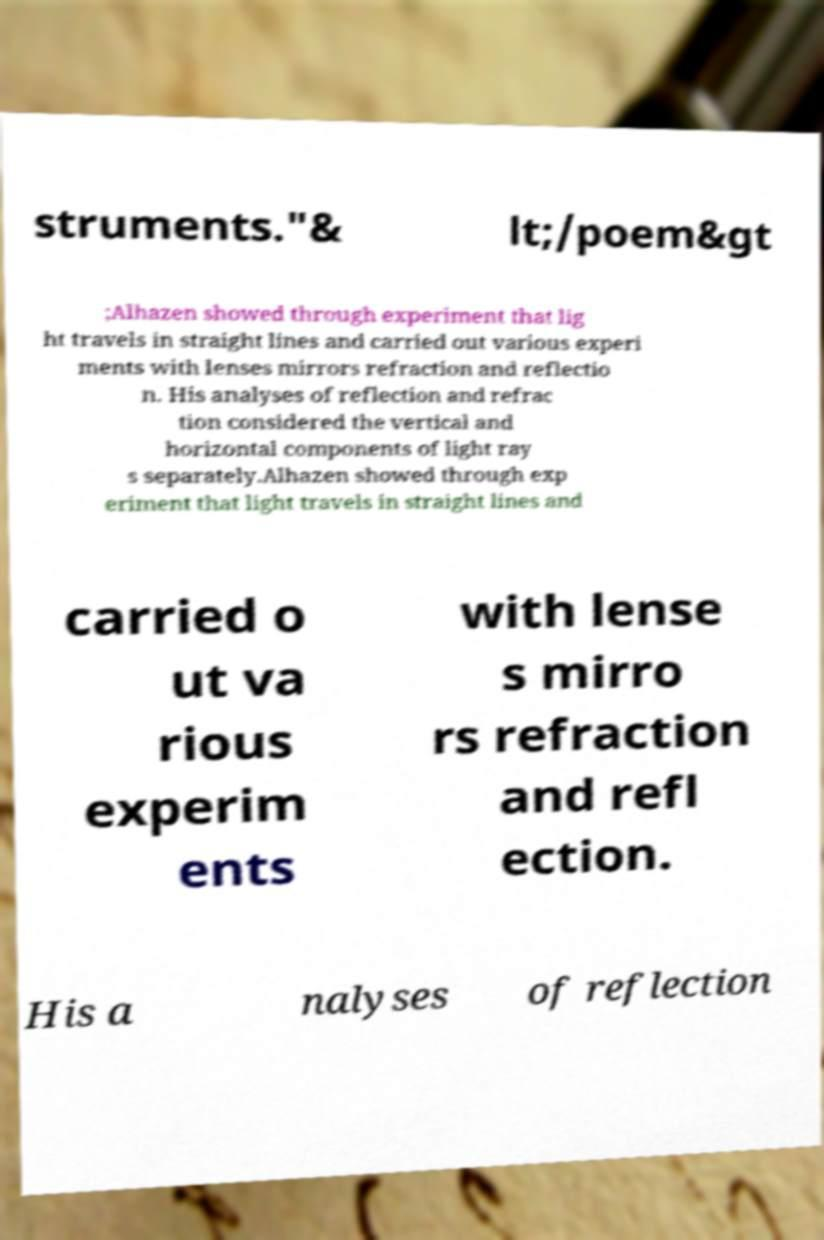Could you assist in decoding the text presented in this image and type it out clearly? struments."& lt;/poem&gt ;Alhazen showed through experiment that lig ht travels in straight lines and carried out various experi ments with lenses mirrors refraction and reflectio n. His analyses of reflection and refrac tion considered the vertical and horizontal components of light ray s separately.Alhazen showed through exp eriment that light travels in straight lines and carried o ut va rious experim ents with lense s mirro rs refraction and refl ection. His a nalyses of reflection 